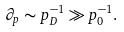<formula> <loc_0><loc_0><loc_500><loc_500>\partial _ { p } \sim p _ { D } ^ { - 1 } \gg p _ { 0 } ^ { - 1 } .</formula> 